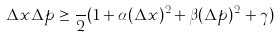<formula> <loc_0><loc_0><loc_500><loc_500>\Delta x \Delta p \geq \frac { } { 2 } ( 1 + \alpha ( \Delta x ) ^ { 2 } + \beta ( \Delta p ) ^ { 2 } + \gamma )</formula> 